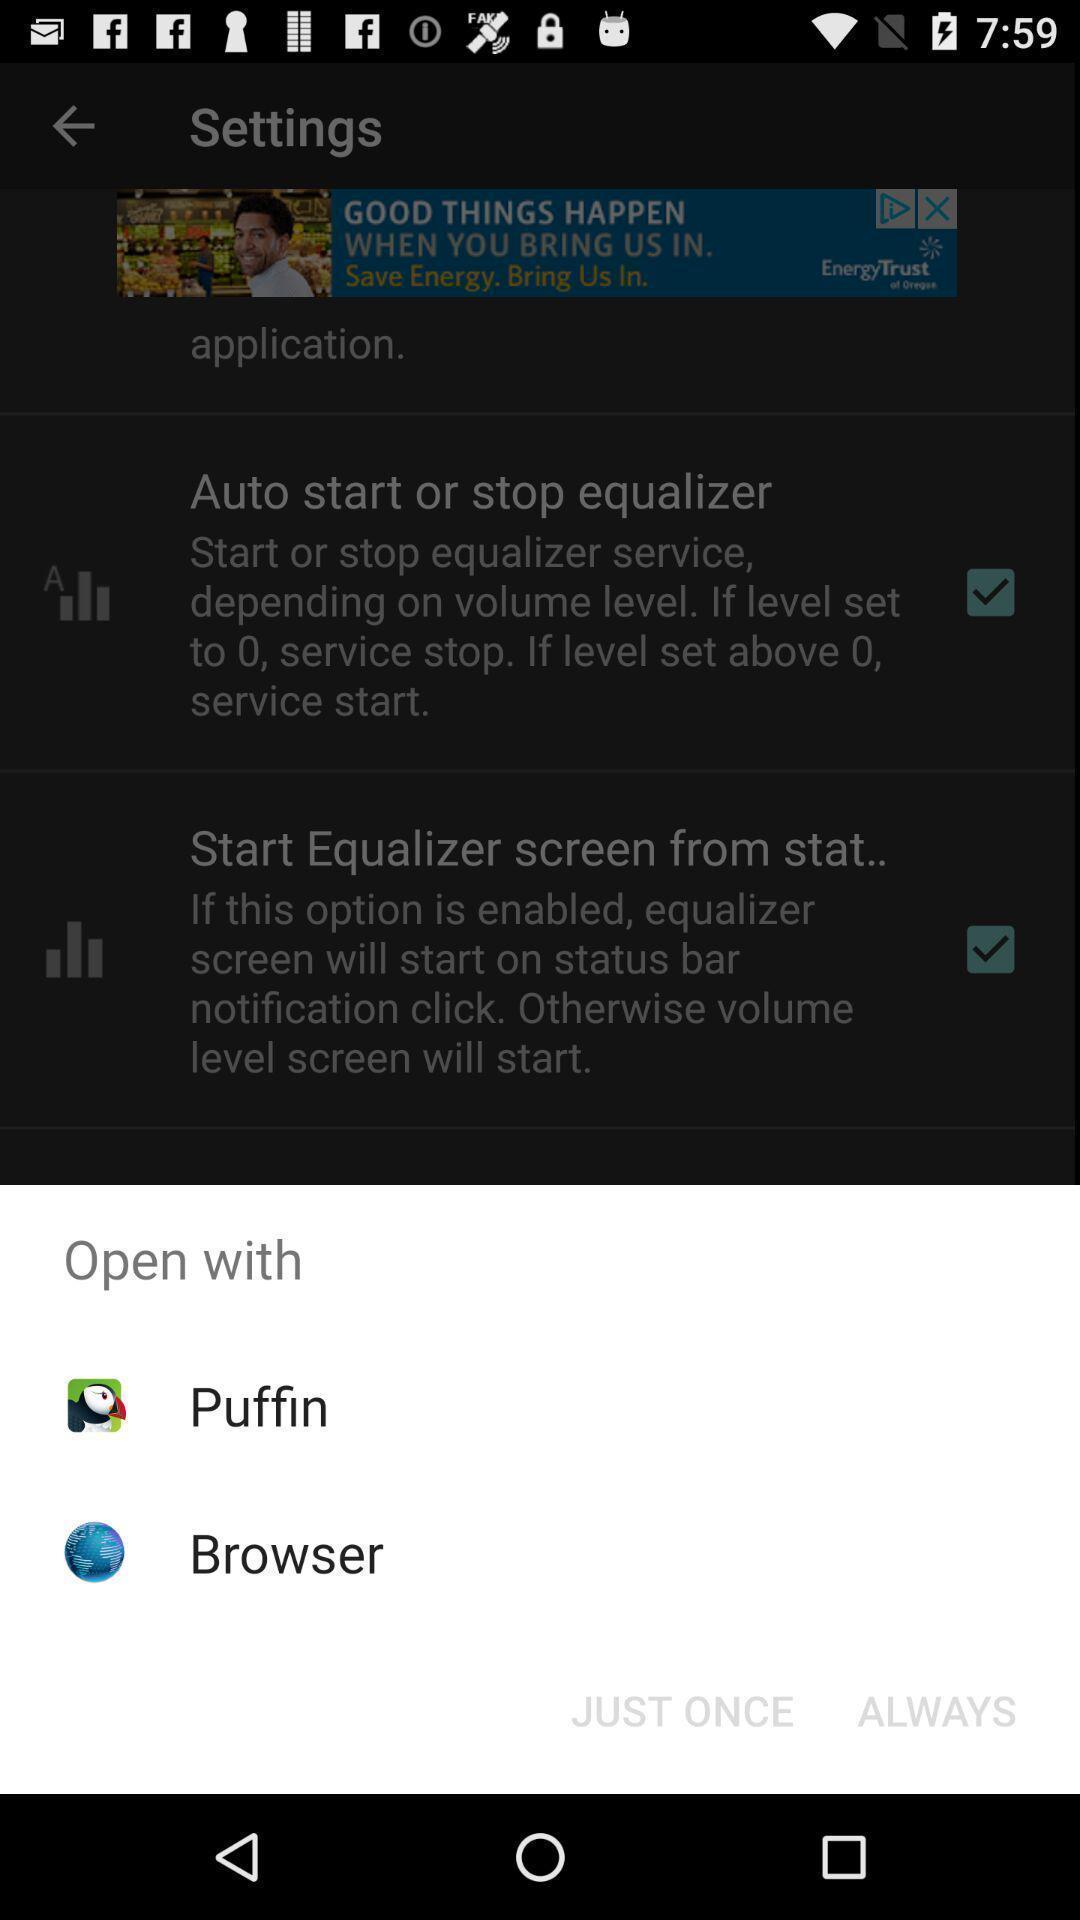What can you discern from this picture? Push up message to open via social application. 